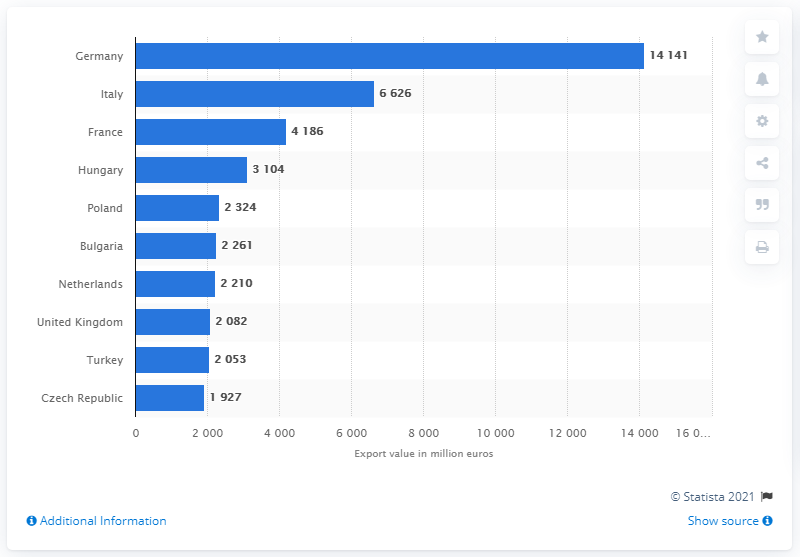Outline some significant characteristics in this image. Romania's top export destination in 2020, besides France and Hungary, was the United Kingdom. In 2020, Romania exported the most to Italy, which was the second country it exported the most to that year. Germany was the leading export partner for Romania in the year 2021. 